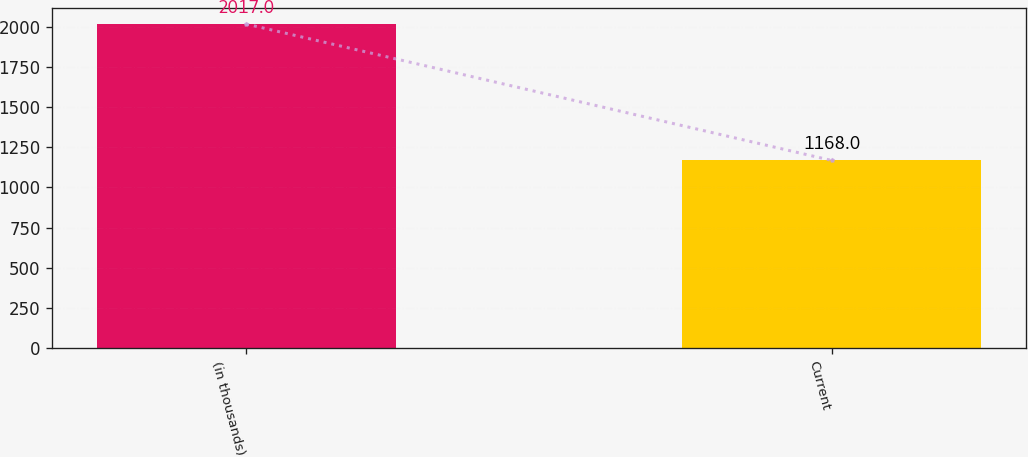Convert chart. <chart><loc_0><loc_0><loc_500><loc_500><bar_chart><fcel>(in thousands)<fcel>Current<nl><fcel>2017<fcel>1168<nl></chart> 